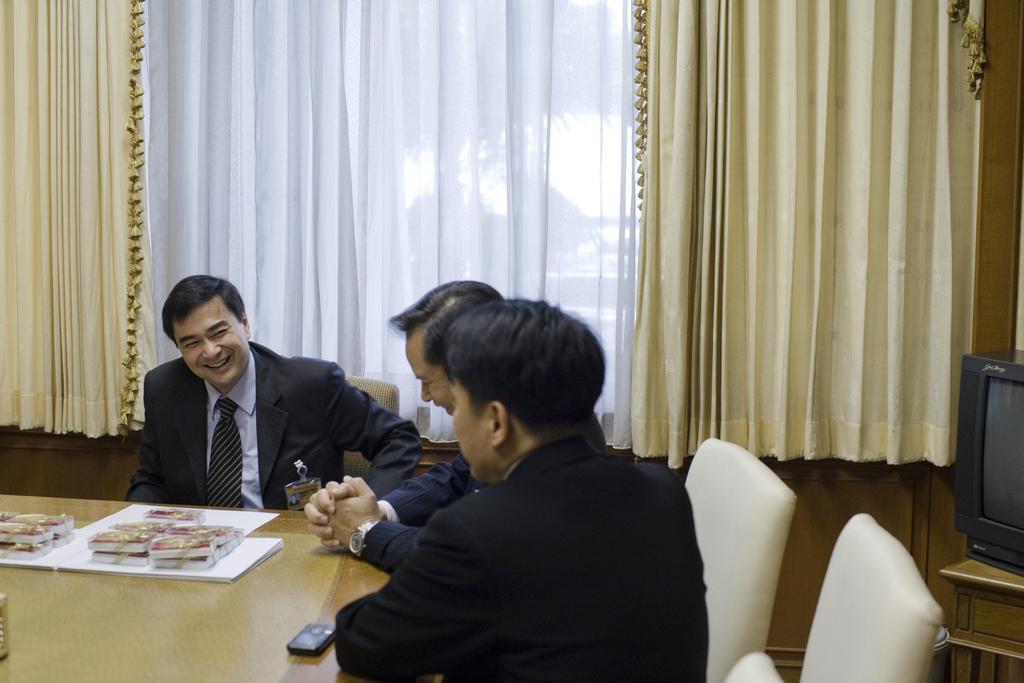Describe this image in one or two sentences. In this image we can see three men sitting on the chairs beside a table containing some books tied with ribbons, some papers, a mobile phone and an object which are placed on it. On the right side we can see the television on a table. On the backside we can see the curtains. 